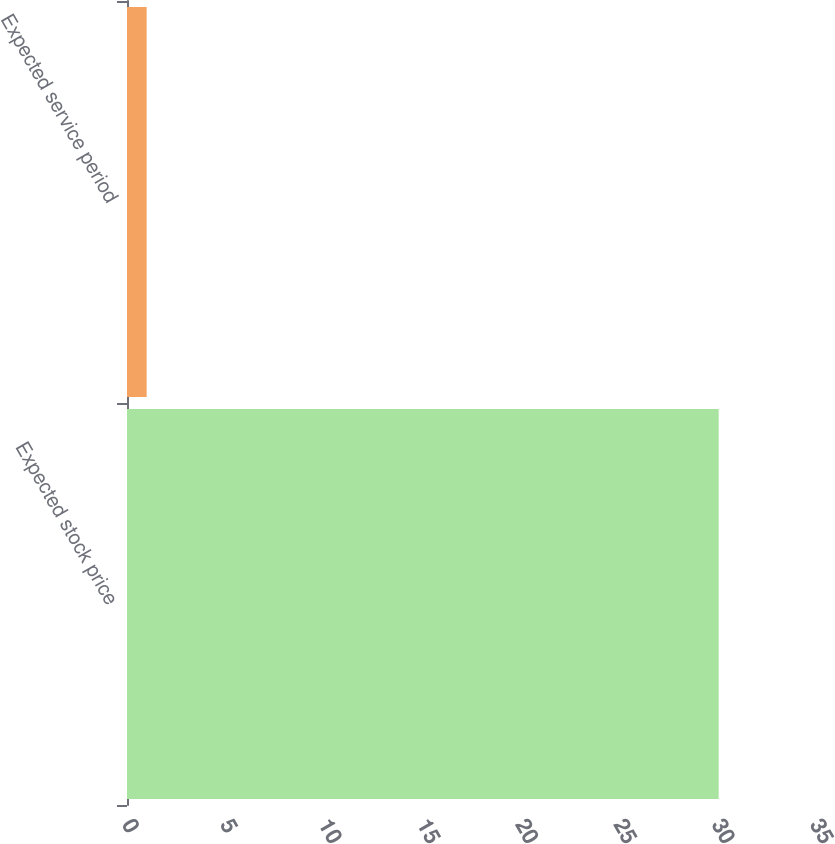<chart> <loc_0><loc_0><loc_500><loc_500><bar_chart><fcel>Expected stock price<fcel>Expected service period<nl><fcel>30.1<fcel>1<nl></chart> 